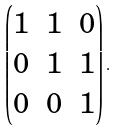Convert formula to latex. <formula><loc_0><loc_0><loc_500><loc_500>\begin{pmatrix} 1 & 1 & 0 \\ 0 & 1 & 1 \\ 0 & 0 & 1 \end{pmatrix} .</formula> 